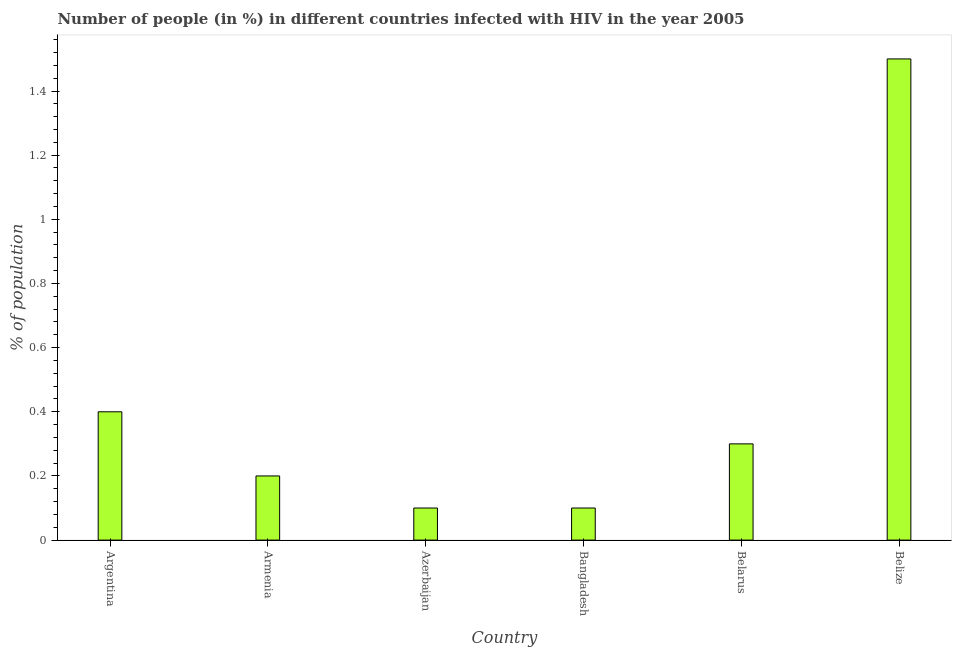Does the graph contain grids?
Your answer should be very brief. No. What is the title of the graph?
Your response must be concise. Number of people (in %) in different countries infected with HIV in the year 2005. What is the label or title of the Y-axis?
Ensure brevity in your answer.  % of population. Across all countries, what is the maximum number of people infected with hiv?
Your answer should be very brief. 1.5. Across all countries, what is the minimum number of people infected with hiv?
Offer a very short reply. 0.1. In which country was the number of people infected with hiv maximum?
Offer a very short reply. Belize. In which country was the number of people infected with hiv minimum?
Your answer should be compact. Azerbaijan. What is the sum of the number of people infected with hiv?
Your response must be concise. 2.6. What is the difference between the number of people infected with hiv in Azerbaijan and Bangladesh?
Offer a very short reply. 0. What is the average number of people infected with hiv per country?
Ensure brevity in your answer.  0.43. What is the median number of people infected with hiv?
Ensure brevity in your answer.  0.25. Is the difference between the number of people infected with hiv in Armenia and Azerbaijan greater than the difference between any two countries?
Your response must be concise. No. In how many countries, is the number of people infected with hiv greater than the average number of people infected with hiv taken over all countries?
Make the answer very short. 1. How many bars are there?
Keep it short and to the point. 6. Are all the bars in the graph horizontal?
Your answer should be compact. No. How many countries are there in the graph?
Your answer should be compact. 6. What is the difference between two consecutive major ticks on the Y-axis?
Give a very brief answer. 0.2. What is the % of population of Armenia?
Your answer should be compact. 0.2. What is the % of population in Azerbaijan?
Give a very brief answer. 0.1. What is the % of population in Bangladesh?
Your answer should be very brief. 0.1. What is the % of population in Belarus?
Provide a succinct answer. 0.3. What is the % of population in Belize?
Offer a very short reply. 1.5. What is the difference between the % of population in Argentina and Azerbaijan?
Keep it short and to the point. 0.3. What is the difference between the % of population in Argentina and Bangladesh?
Provide a succinct answer. 0.3. What is the difference between the % of population in Argentina and Belarus?
Make the answer very short. 0.1. What is the difference between the % of population in Armenia and Azerbaijan?
Provide a succinct answer. 0.1. What is the difference between the % of population in Armenia and Bangladesh?
Keep it short and to the point. 0.1. What is the difference between the % of population in Armenia and Belize?
Keep it short and to the point. -1.3. What is the difference between the % of population in Bangladesh and Belize?
Give a very brief answer. -1.4. What is the difference between the % of population in Belarus and Belize?
Your answer should be compact. -1.2. What is the ratio of the % of population in Argentina to that in Armenia?
Make the answer very short. 2. What is the ratio of the % of population in Argentina to that in Azerbaijan?
Provide a succinct answer. 4. What is the ratio of the % of population in Argentina to that in Bangladesh?
Your answer should be very brief. 4. What is the ratio of the % of population in Argentina to that in Belarus?
Your answer should be very brief. 1.33. What is the ratio of the % of population in Argentina to that in Belize?
Offer a terse response. 0.27. What is the ratio of the % of population in Armenia to that in Belarus?
Give a very brief answer. 0.67. What is the ratio of the % of population in Armenia to that in Belize?
Keep it short and to the point. 0.13. What is the ratio of the % of population in Azerbaijan to that in Bangladesh?
Offer a very short reply. 1. What is the ratio of the % of population in Azerbaijan to that in Belarus?
Your answer should be very brief. 0.33. What is the ratio of the % of population in Azerbaijan to that in Belize?
Make the answer very short. 0.07. What is the ratio of the % of population in Bangladesh to that in Belarus?
Ensure brevity in your answer.  0.33. What is the ratio of the % of population in Bangladesh to that in Belize?
Your answer should be compact. 0.07. 